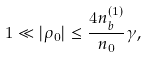<formula> <loc_0><loc_0><loc_500><loc_500>1 \ll | \rho _ { 0 } | \leq \frac { 4 n _ { b } ^ { ( 1 ) } } { n _ { 0 } } \gamma ,</formula> 